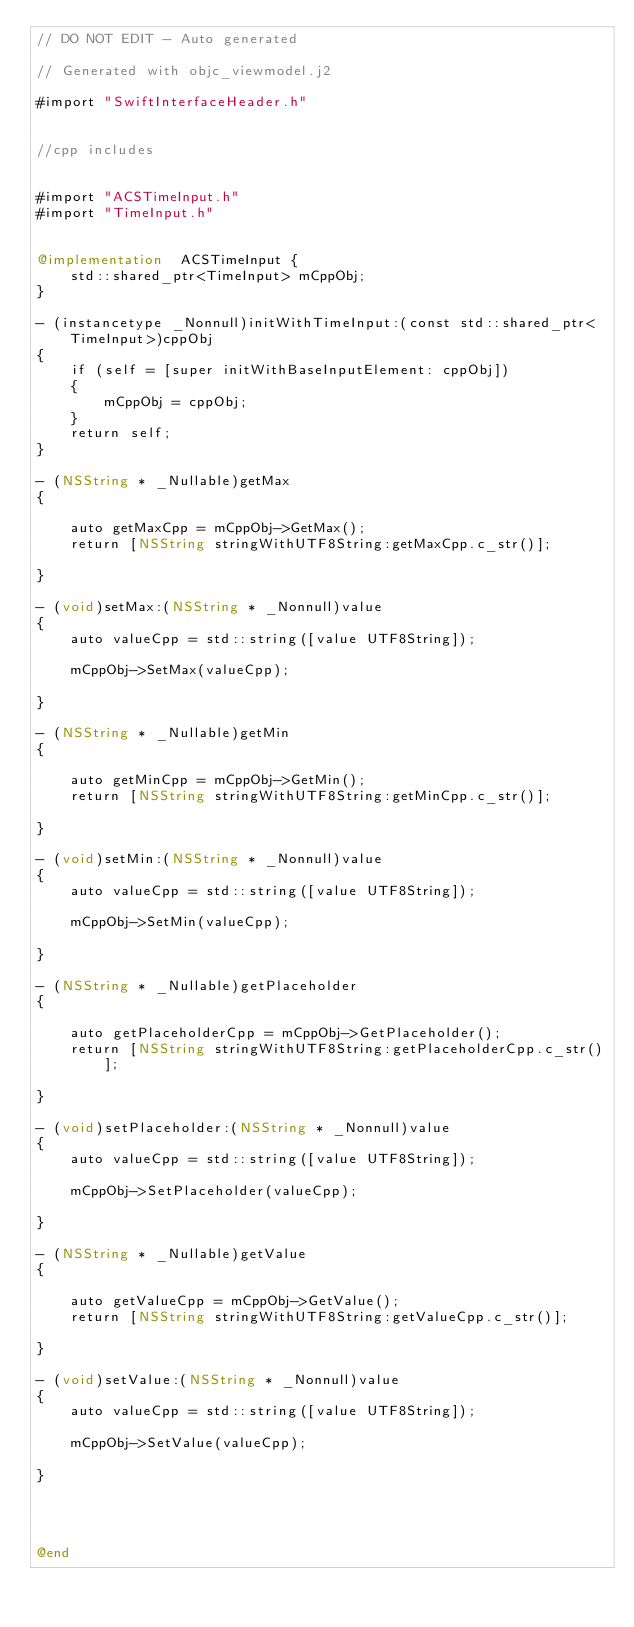<code> <loc_0><loc_0><loc_500><loc_500><_ObjectiveC_>// DO NOT EDIT - Auto generated

// Generated with objc_viewmodel.j2

#import "SwiftInterfaceHeader.h"


//cpp includes


#import "ACSTimeInput.h"
#import "TimeInput.h"


@implementation  ACSTimeInput {
    std::shared_ptr<TimeInput> mCppObj;
}

- (instancetype _Nonnull)initWithTimeInput:(const std::shared_ptr<TimeInput>)cppObj
{
    if (self = [super initWithBaseInputElement: cppObj])
    {
        mCppObj = cppObj;
    }
    return self;
}

- (NSString * _Nullable)getMax
{
 
    auto getMaxCpp = mCppObj->GetMax();
    return [NSString stringWithUTF8String:getMaxCpp.c_str()];

}

- (void)setMax:(NSString * _Nonnull)value
{
    auto valueCpp = std::string([value UTF8String]);
 
    mCppObj->SetMax(valueCpp);
    
}

- (NSString * _Nullable)getMin
{
 
    auto getMinCpp = mCppObj->GetMin();
    return [NSString stringWithUTF8String:getMinCpp.c_str()];

}

- (void)setMin:(NSString * _Nonnull)value
{
    auto valueCpp = std::string([value UTF8String]);
 
    mCppObj->SetMin(valueCpp);
    
}

- (NSString * _Nullable)getPlaceholder
{
 
    auto getPlaceholderCpp = mCppObj->GetPlaceholder();
    return [NSString stringWithUTF8String:getPlaceholderCpp.c_str()];

}

- (void)setPlaceholder:(NSString * _Nonnull)value
{
    auto valueCpp = std::string([value UTF8String]);
 
    mCppObj->SetPlaceholder(valueCpp);
    
}

- (NSString * _Nullable)getValue
{
 
    auto getValueCpp = mCppObj->GetValue();
    return [NSString stringWithUTF8String:getValueCpp.c_str()];

}

- (void)setValue:(NSString * _Nonnull)value
{
    auto valueCpp = std::string([value UTF8String]);
 
    mCppObj->SetValue(valueCpp);
    
}




@end
</code> 